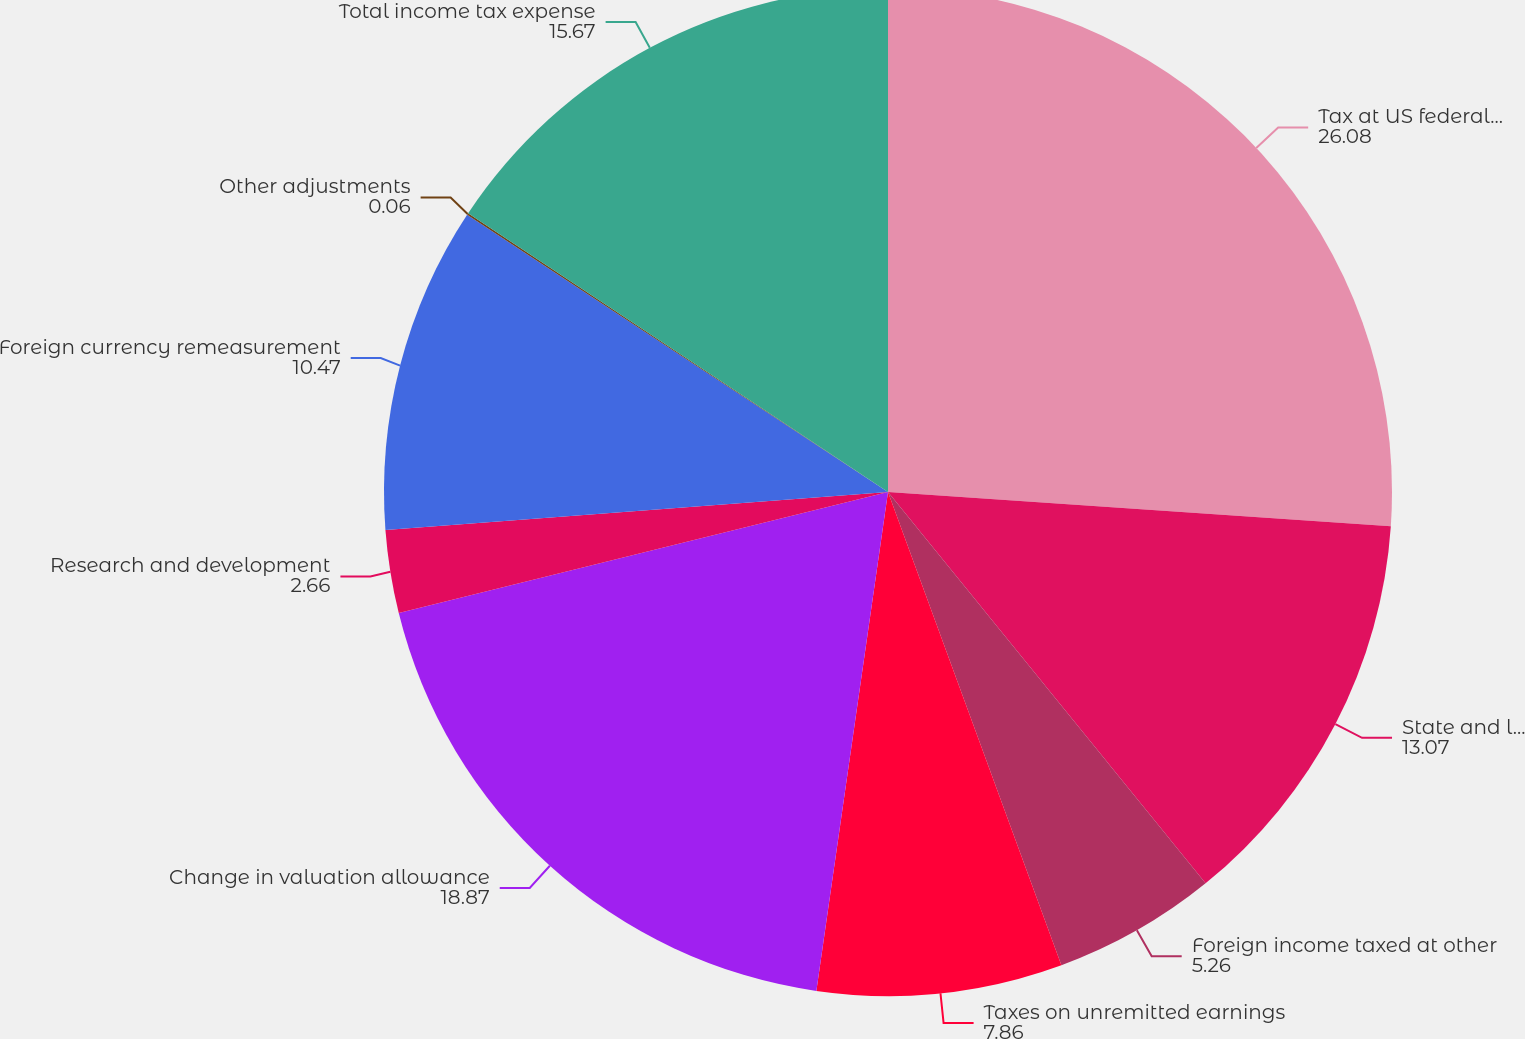<chart> <loc_0><loc_0><loc_500><loc_500><pie_chart><fcel>Tax at US federal statutory<fcel>State and local tax expense<fcel>Foreign income taxed at other<fcel>Taxes on unremitted earnings<fcel>Change in valuation allowance<fcel>Research and development<fcel>Foreign currency remeasurement<fcel>Other adjustments<fcel>Total income tax expense<nl><fcel>26.08%<fcel>13.07%<fcel>5.26%<fcel>7.86%<fcel>18.87%<fcel>2.66%<fcel>10.47%<fcel>0.06%<fcel>15.67%<nl></chart> 